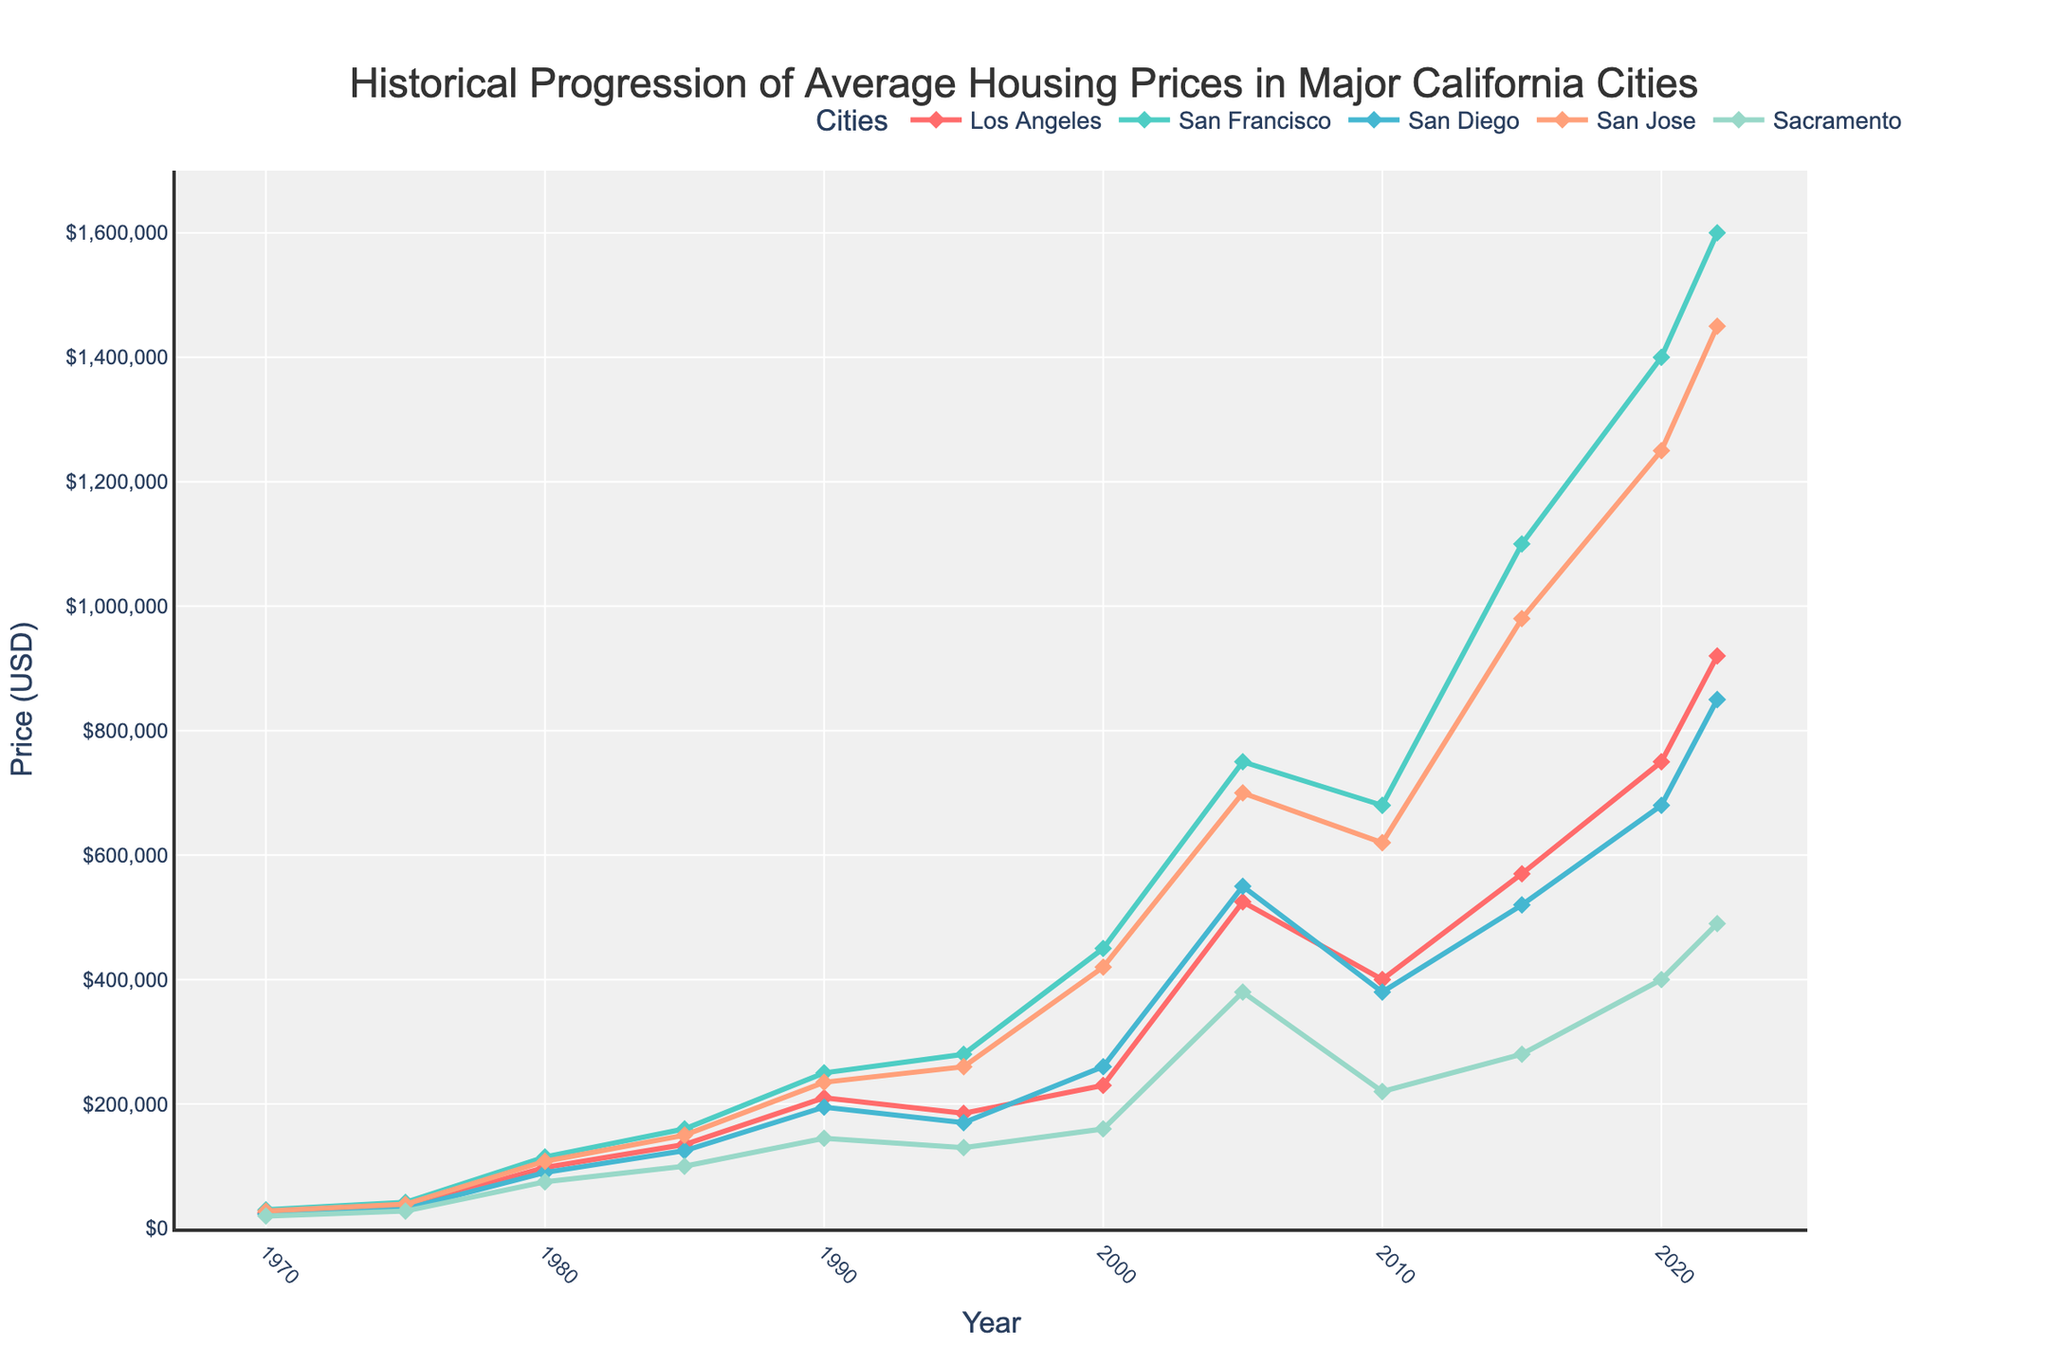What city had the highest average housing price in 2022? The line chart shows the historical progression of average housing prices for major California cities. For 2022, we need to locate the line that reaches the highest vertical point. The line representing San Francisco is the highest in 2022.
Answer: San Francisco How much did the average housing price in San Diego increase from 2015 to 2022? To find the increase in average housing price, we need to refer to the data points for San Diego in 2015 and 2022. The price in 2015 was $520,000, and in 2022 it was $850,000. Subtract 520,000 from 850,000 to get the increase.
Answer: $330,000 Which city experienced the sharpest increase in housing prices between 1970 and 2022? The sharpest increase can be determined by finding the difference in housing prices between 1970 and 2022 for each city and identifying the largest increase. By referring to the end of each line, San Francisco shows the biggest increase, going from $30,000 in 1970 to $1,600,000 in 2022.
Answer: San Francisco By how much did the average housing price in Los Angeles change between the housing market peak in 2005 and the bottom in 2010? To determine the change, note the prices in Los Angeles for 2005 and 2010. In 2005, it was $525,000, and in 2010, it was $400,000. Subtract 400,000 from 525,000 to find the change.
Answer: $125,000 Which city had the smallest average housing price in 1970? The smallest average housing price in 1970 can be found by looking at the lowest point on the graph for the year 1970. San Diego had the smallest average housing price, which was $20,000.
Answer: Sacramento Between 1980 and 1990, which city had the smallest relative increase in housing prices? Calculate the relative increase for each city as (price in 1990 - price in 1980) / price in 1980. Los Angeles: ($210,000 - $98,000) / $98,000 ≈ 1.14; San Francisco: ($250,000 - $115,000) / $115,000 ≈ 1.17; San Diego: ($195,000 - $90,000) / $90,000 ≈ 1.17; San Jose: ($235,000 - $108,000) / $108,000 ≈ 1.18; Sacramento: ($145,000 - $75,000) / $75,000 ≈ 0.93. Sacramento has the smallest relative increase.
Answer: Sacramento On the graph, which city crosses the $1,000,000 mark first, and in which year? Find where each city's line surpasses the $1,000,000 mark. San Francisco's line crosses this mark first in the year 2015.
Answer: San Francisco, 2015 What was the difference between the highest and lowest average housing prices in California cities in 2000? Identify the highest and lowest housing prices in 2000. The highest is in San Francisco with $450,000, and the lowest is in Sacramento with $160,000. Subtract the lowest from the highest to find the difference.
Answer: $290,000 